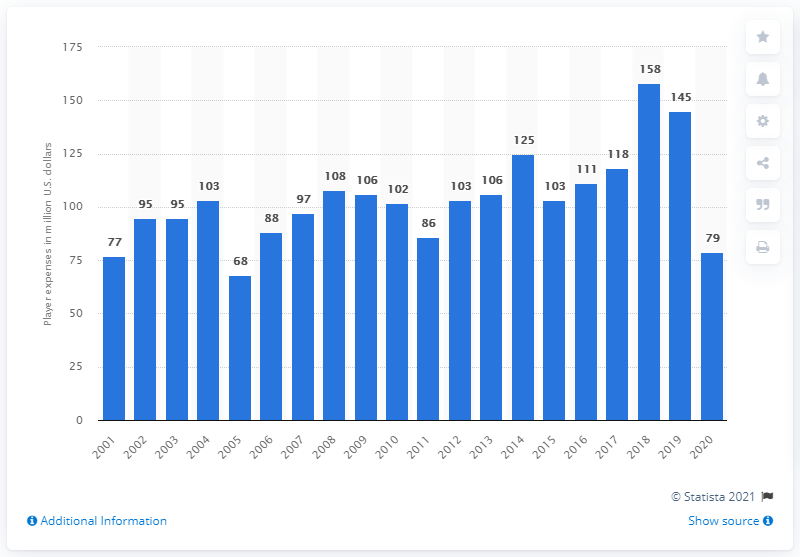Point out several critical features in this image. In 2020, the payroll of the Arizona Diamondbacks was approximately $79 million in dollars. 